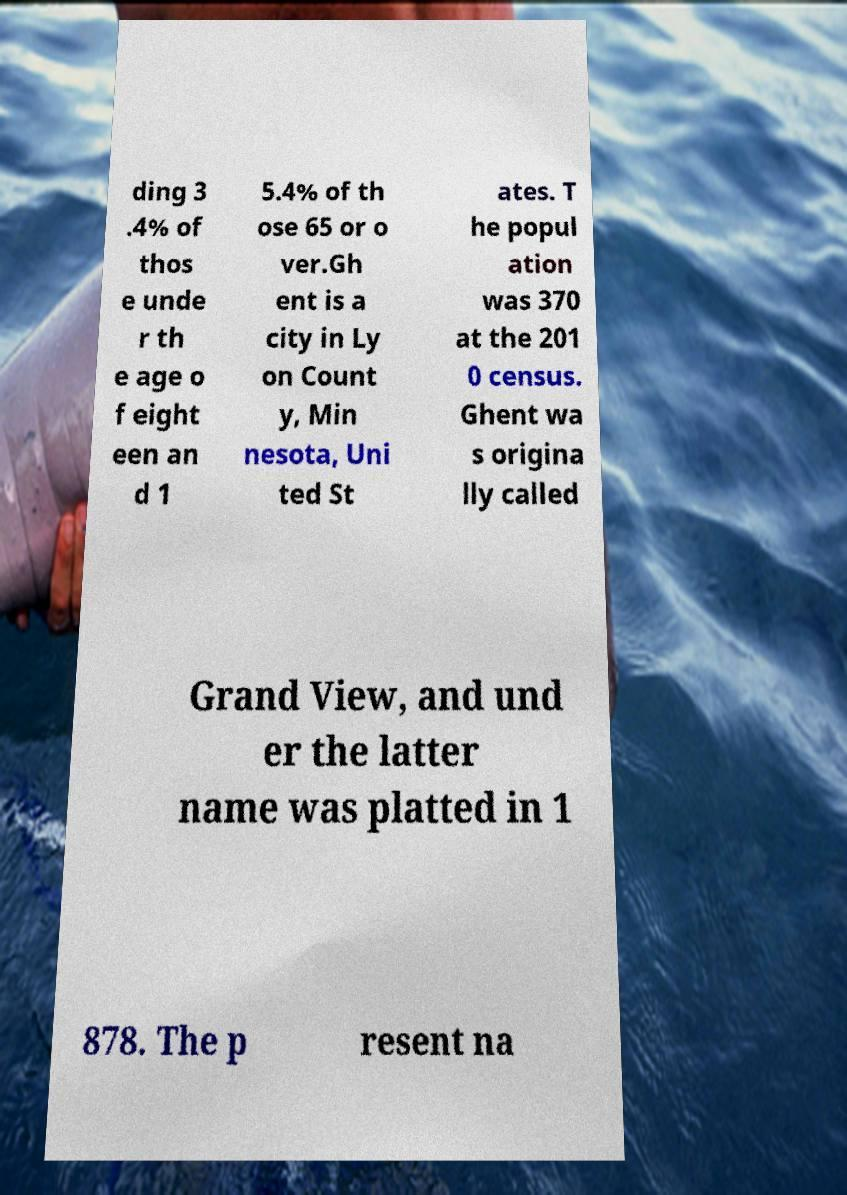Can you read and provide the text displayed in the image?This photo seems to have some interesting text. Can you extract and type it out for me? ding 3 .4% of thos e unde r th e age o f eight een an d 1 5.4% of th ose 65 or o ver.Gh ent is a city in Ly on Count y, Min nesota, Uni ted St ates. T he popul ation was 370 at the 201 0 census. Ghent wa s origina lly called Grand View, and und er the latter name was platted in 1 878. The p resent na 